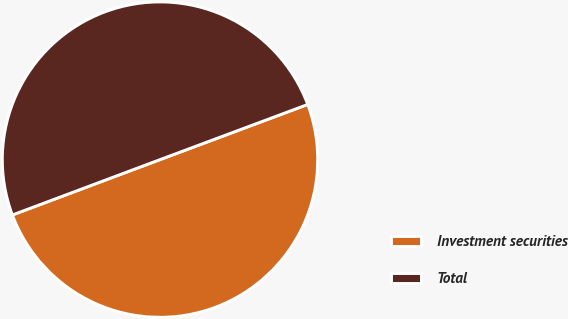<chart> <loc_0><loc_0><loc_500><loc_500><pie_chart><fcel>Investment securities<fcel>Total<nl><fcel>49.98%<fcel>50.02%<nl></chart> 